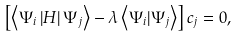Convert formula to latex. <formula><loc_0><loc_0><loc_500><loc_500>\left [ \left \langle \Psi _ { i } \left | H \right | \Psi _ { j } \right \rangle - \lambda \left \langle \Psi _ { i } | \Psi _ { j } \right \rangle \right ] c _ { j } = 0 ,</formula> 